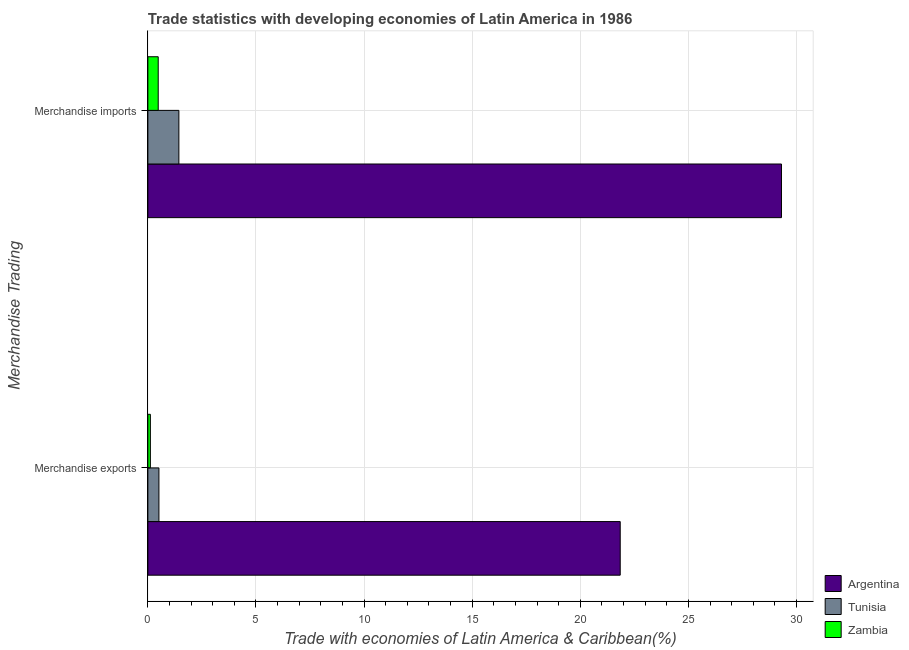How many groups of bars are there?
Your answer should be very brief. 2. Are the number of bars per tick equal to the number of legend labels?
Provide a succinct answer. Yes. Are the number of bars on each tick of the Y-axis equal?
Provide a short and direct response. Yes. How many bars are there on the 1st tick from the top?
Your answer should be very brief. 3. What is the merchandise exports in Argentina?
Ensure brevity in your answer.  21.85. Across all countries, what is the maximum merchandise exports?
Your response must be concise. 21.85. Across all countries, what is the minimum merchandise exports?
Make the answer very short. 0.12. In which country was the merchandise exports minimum?
Make the answer very short. Zambia. What is the total merchandise exports in the graph?
Provide a succinct answer. 22.47. What is the difference between the merchandise exports in Argentina and that in Tunisia?
Provide a short and direct response. 21.33. What is the difference between the merchandise imports in Argentina and the merchandise exports in Zambia?
Ensure brevity in your answer.  29.19. What is the average merchandise exports per country?
Offer a very short reply. 7.49. What is the difference between the merchandise exports and merchandise imports in Zambia?
Your answer should be very brief. -0.36. In how many countries, is the merchandise exports greater than 13 %?
Ensure brevity in your answer.  1. What is the ratio of the merchandise exports in Argentina to that in Zambia?
Your answer should be compact. 188.27. Is the merchandise imports in Argentina less than that in Tunisia?
Your answer should be compact. No. In how many countries, is the merchandise imports greater than the average merchandise imports taken over all countries?
Provide a succinct answer. 1. What does the 3rd bar from the top in Merchandise imports represents?
Your response must be concise. Argentina. What does the 2nd bar from the bottom in Merchandise imports represents?
Provide a succinct answer. Tunisia. How many countries are there in the graph?
Make the answer very short. 3. Does the graph contain grids?
Keep it short and to the point. Yes. How many legend labels are there?
Offer a terse response. 3. How are the legend labels stacked?
Make the answer very short. Vertical. What is the title of the graph?
Provide a succinct answer. Trade statistics with developing economies of Latin America in 1986. What is the label or title of the X-axis?
Give a very brief answer. Trade with economies of Latin America & Caribbean(%). What is the label or title of the Y-axis?
Your answer should be very brief. Merchandise Trading. What is the Trade with economies of Latin America & Caribbean(%) in Argentina in Merchandise exports?
Ensure brevity in your answer.  21.85. What is the Trade with economies of Latin America & Caribbean(%) of Tunisia in Merchandise exports?
Offer a terse response. 0.51. What is the Trade with economies of Latin America & Caribbean(%) in Zambia in Merchandise exports?
Your answer should be very brief. 0.12. What is the Trade with economies of Latin America & Caribbean(%) in Argentina in Merchandise imports?
Your response must be concise. 29.3. What is the Trade with economies of Latin America & Caribbean(%) of Tunisia in Merchandise imports?
Provide a short and direct response. 1.43. What is the Trade with economies of Latin America & Caribbean(%) in Zambia in Merchandise imports?
Provide a short and direct response. 0.48. Across all Merchandise Trading, what is the maximum Trade with economies of Latin America & Caribbean(%) of Argentina?
Your answer should be very brief. 29.3. Across all Merchandise Trading, what is the maximum Trade with economies of Latin America & Caribbean(%) of Tunisia?
Your response must be concise. 1.43. Across all Merchandise Trading, what is the maximum Trade with economies of Latin America & Caribbean(%) in Zambia?
Offer a very short reply. 0.48. Across all Merchandise Trading, what is the minimum Trade with economies of Latin America & Caribbean(%) in Argentina?
Provide a succinct answer. 21.85. Across all Merchandise Trading, what is the minimum Trade with economies of Latin America & Caribbean(%) in Tunisia?
Your answer should be very brief. 0.51. Across all Merchandise Trading, what is the minimum Trade with economies of Latin America & Caribbean(%) in Zambia?
Your answer should be compact. 0.12. What is the total Trade with economies of Latin America & Caribbean(%) in Argentina in the graph?
Your answer should be very brief. 51.15. What is the total Trade with economies of Latin America & Caribbean(%) of Tunisia in the graph?
Provide a succinct answer. 1.95. What is the total Trade with economies of Latin America & Caribbean(%) in Zambia in the graph?
Offer a very short reply. 0.59. What is the difference between the Trade with economies of Latin America & Caribbean(%) of Argentina in Merchandise exports and that in Merchandise imports?
Offer a terse response. -7.46. What is the difference between the Trade with economies of Latin America & Caribbean(%) of Tunisia in Merchandise exports and that in Merchandise imports?
Keep it short and to the point. -0.92. What is the difference between the Trade with economies of Latin America & Caribbean(%) in Zambia in Merchandise exports and that in Merchandise imports?
Provide a succinct answer. -0.36. What is the difference between the Trade with economies of Latin America & Caribbean(%) of Argentina in Merchandise exports and the Trade with economies of Latin America & Caribbean(%) of Tunisia in Merchandise imports?
Your response must be concise. 20.41. What is the difference between the Trade with economies of Latin America & Caribbean(%) of Argentina in Merchandise exports and the Trade with economies of Latin America & Caribbean(%) of Zambia in Merchandise imports?
Provide a short and direct response. 21.37. What is the difference between the Trade with economies of Latin America & Caribbean(%) of Tunisia in Merchandise exports and the Trade with economies of Latin America & Caribbean(%) of Zambia in Merchandise imports?
Offer a terse response. 0.03. What is the average Trade with economies of Latin America & Caribbean(%) in Argentina per Merchandise Trading?
Give a very brief answer. 25.57. What is the average Trade with economies of Latin America & Caribbean(%) of Tunisia per Merchandise Trading?
Ensure brevity in your answer.  0.97. What is the average Trade with economies of Latin America & Caribbean(%) of Zambia per Merchandise Trading?
Provide a short and direct response. 0.3. What is the difference between the Trade with economies of Latin America & Caribbean(%) in Argentina and Trade with economies of Latin America & Caribbean(%) in Tunisia in Merchandise exports?
Keep it short and to the point. 21.33. What is the difference between the Trade with economies of Latin America & Caribbean(%) in Argentina and Trade with economies of Latin America & Caribbean(%) in Zambia in Merchandise exports?
Offer a very short reply. 21.73. What is the difference between the Trade with economies of Latin America & Caribbean(%) of Tunisia and Trade with economies of Latin America & Caribbean(%) of Zambia in Merchandise exports?
Provide a succinct answer. 0.4. What is the difference between the Trade with economies of Latin America & Caribbean(%) of Argentina and Trade with economies of Latin America & Caribbean(%) of Tunisia in Merchandise imports?
Make the answer very short. 27.87. What is the difference between the Trade with economies of Latin America & Caribbean(%) in Argentina and Trade with economies of Latin America & Caribbean(%) in Zambia in Merchandise imports?
Offer a very short reply. 28.82. What is the difference between the Trade with economies of Latin America & Caribbean(%) of Tunisia and Trade with economies of Latin America & Caribbean(%) of Zambia in Merchandise imports?
Ensure brevity in your answer.  0.96. What is the ratio of the Trade with economies of Latin America & Caribbean(%) of Argentina in Merchandise exports to that in Merchandise imports?
Keep it short and to the point. 0.75. What is the ratio of the Trade with economies of Latin America & Caribbean(%) of Tunisia in Merchandise exports to that in Merchandise imports?
Offer a very short reply. 0.36. What is the ratio of the Trade with economies of Latin America & Caribbean(%) of Zambia in Merchandise exports to that in Merchandise imports?
Offer a very short reply. 0.24. What is the difference between the highest and the second highest Trade with economies of Latin America & Caribbean(%) in Argentina?
Offer a very short reply. 7.46. What is the difference between the highest and the second highest Trade with economies of Latin America & Caribbean(%) in Tunisia?
Keep it short and to the point. 0.92. What is the difference between the highest and the second highest Trade with economies of Latin America & Caribbean(%) of Zambia?
Provide a succinct answer. 0.36. What is the difference between the highest and the lowest Trade with economies of Latin America & Caribbean(%) of Argentina?
Your answer should be compact. 7.46. What is the difference between the highest and the lowest Trade with economies of Latin America & Caribbean(%) of Tunisia?
Provide a succinct answer. 0.92. What is the difference between the highest and the lowest Trade with economies of Latin America & Caribbean(%) in Zambia?
Your answer should be compact. 0.36. 